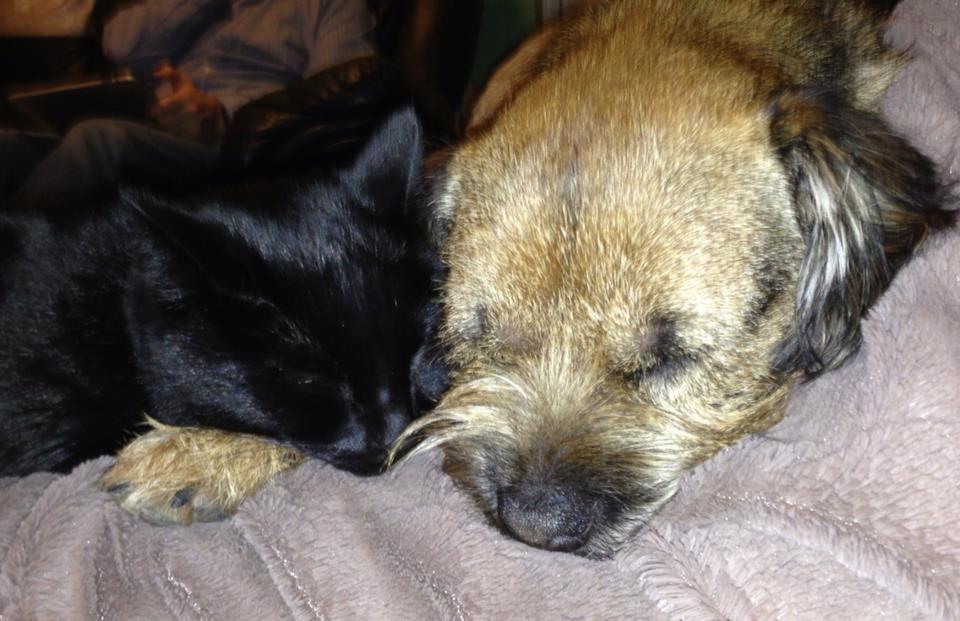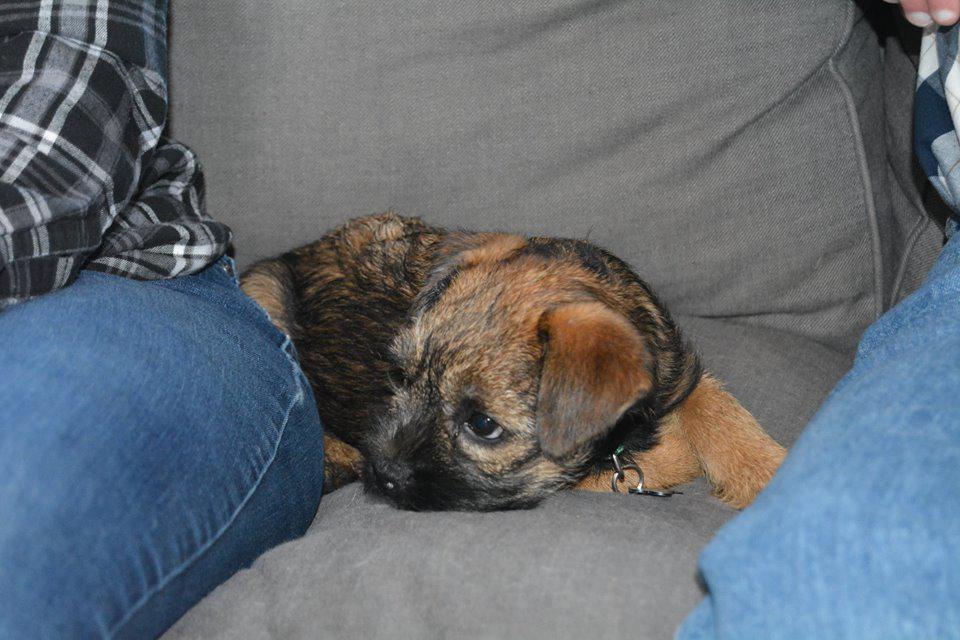The first image is the image on the left, the second image is the image on the right. For the images displayed, is the sentence "The left and right image contains the same number of dogs with at least one standing." factually correct? Answer yes or no. No. The first image is the image on the left, the second image is the image on the right. Examine the images to the left and right. Is the description "The right image features one dog reclining on something soft and looking at the camera, and the left image shows a dog in an upright pose." accurate? Answer yes or no. No. 